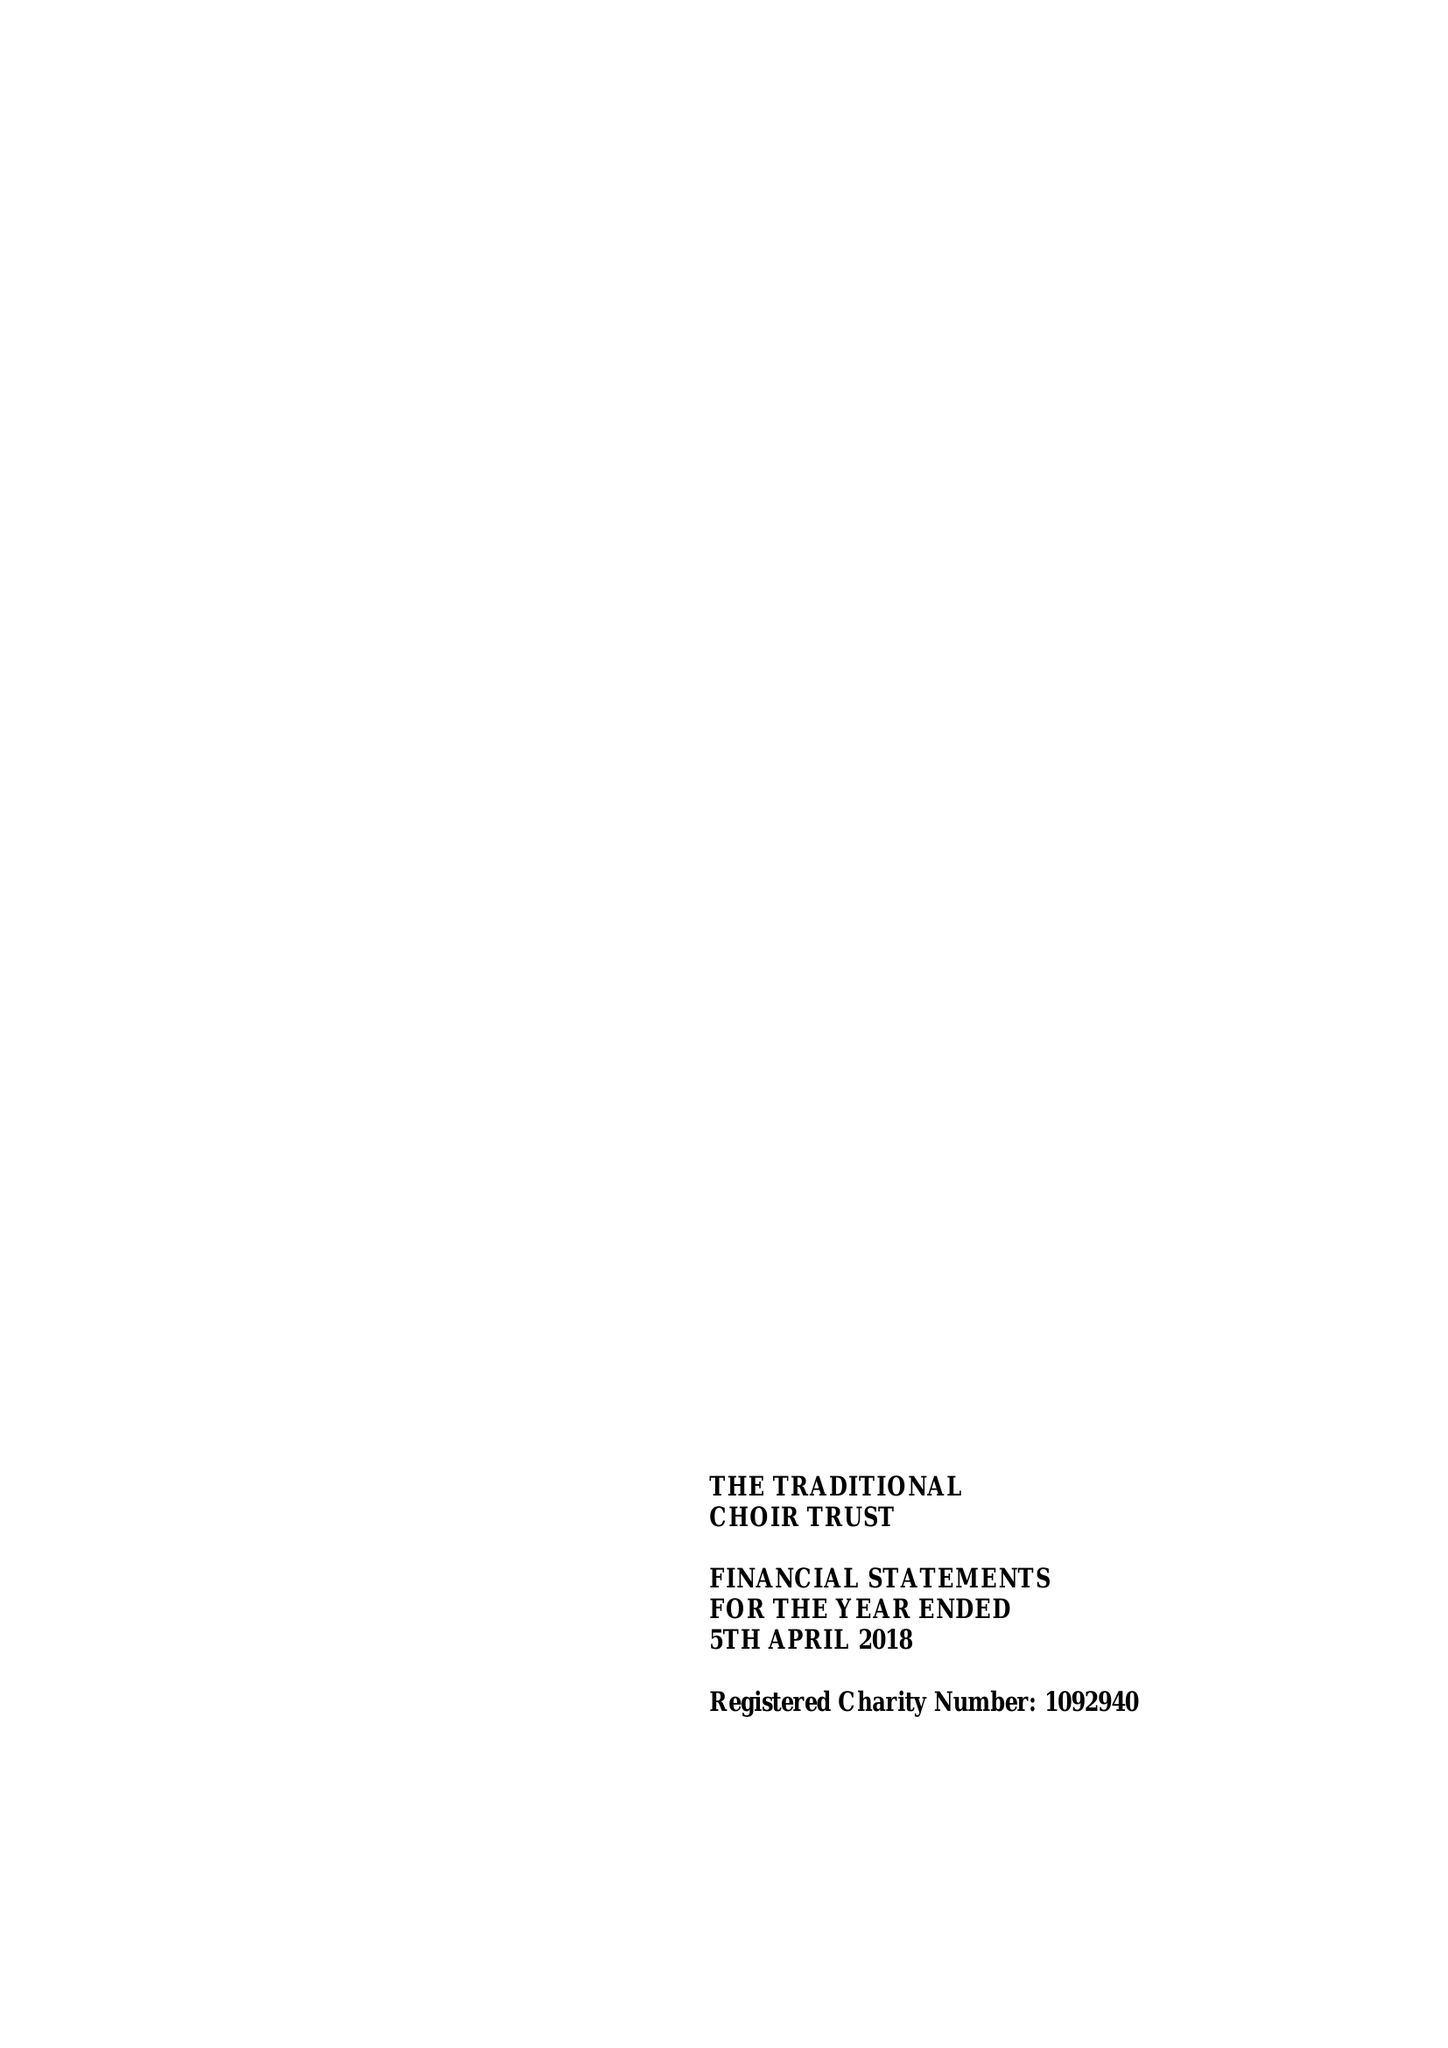What is the value for the charity_name?
Answer the question using a single word or phrase. The Traditional Choir Trust 